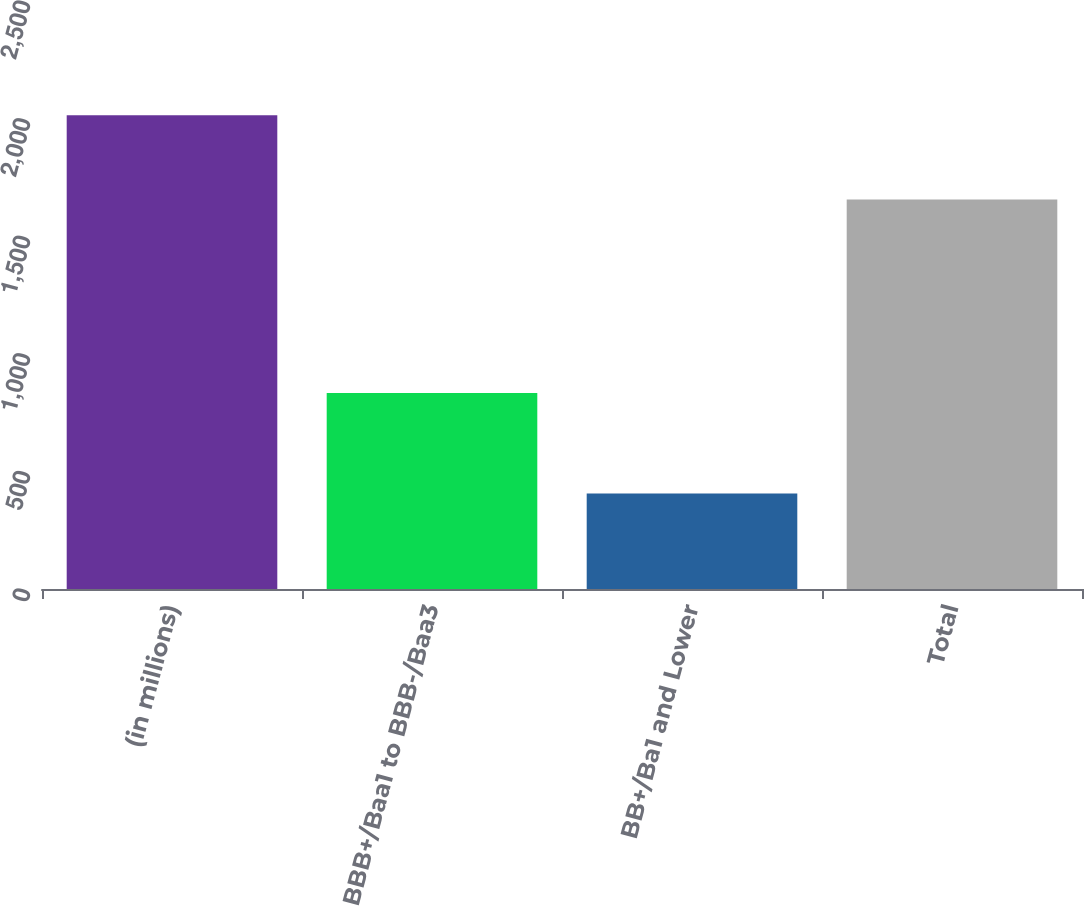<chart> <loc_0><loc_0><loc_500><loc_500><bar_chart><fcel>(in millions)<fcel>BBB+/Baa1 to BBB-/Baa3<fcel>BB+/Ba1 and Lower<fcel>Total<nl><fcel>2014<fcel>833<fcel>406<fcel>1656<nl></chart> 